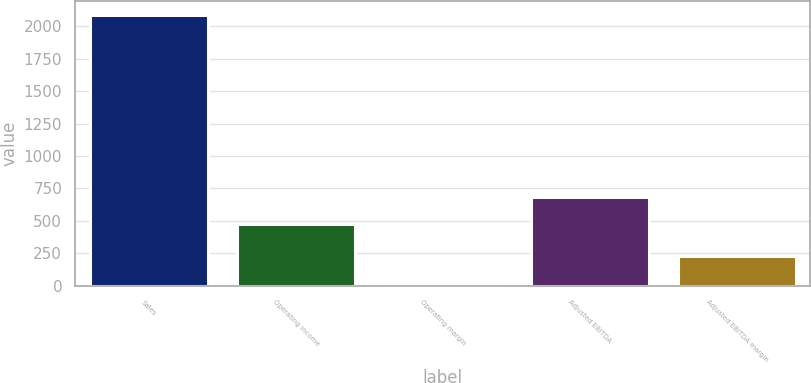<chart> <loc_0><loc_0><loc_500><loc_500><bar_chart><fcel>Sales<fcel>Operating income<fcel>Operating margin<fcel>Adjusted EBITDA<fcel>Adjusted EBITDA margin<nl><fcel>2087.1<fcel>476.7<fcel>22.8<fcel>683.13<fcel>229.23<nl></chart> 